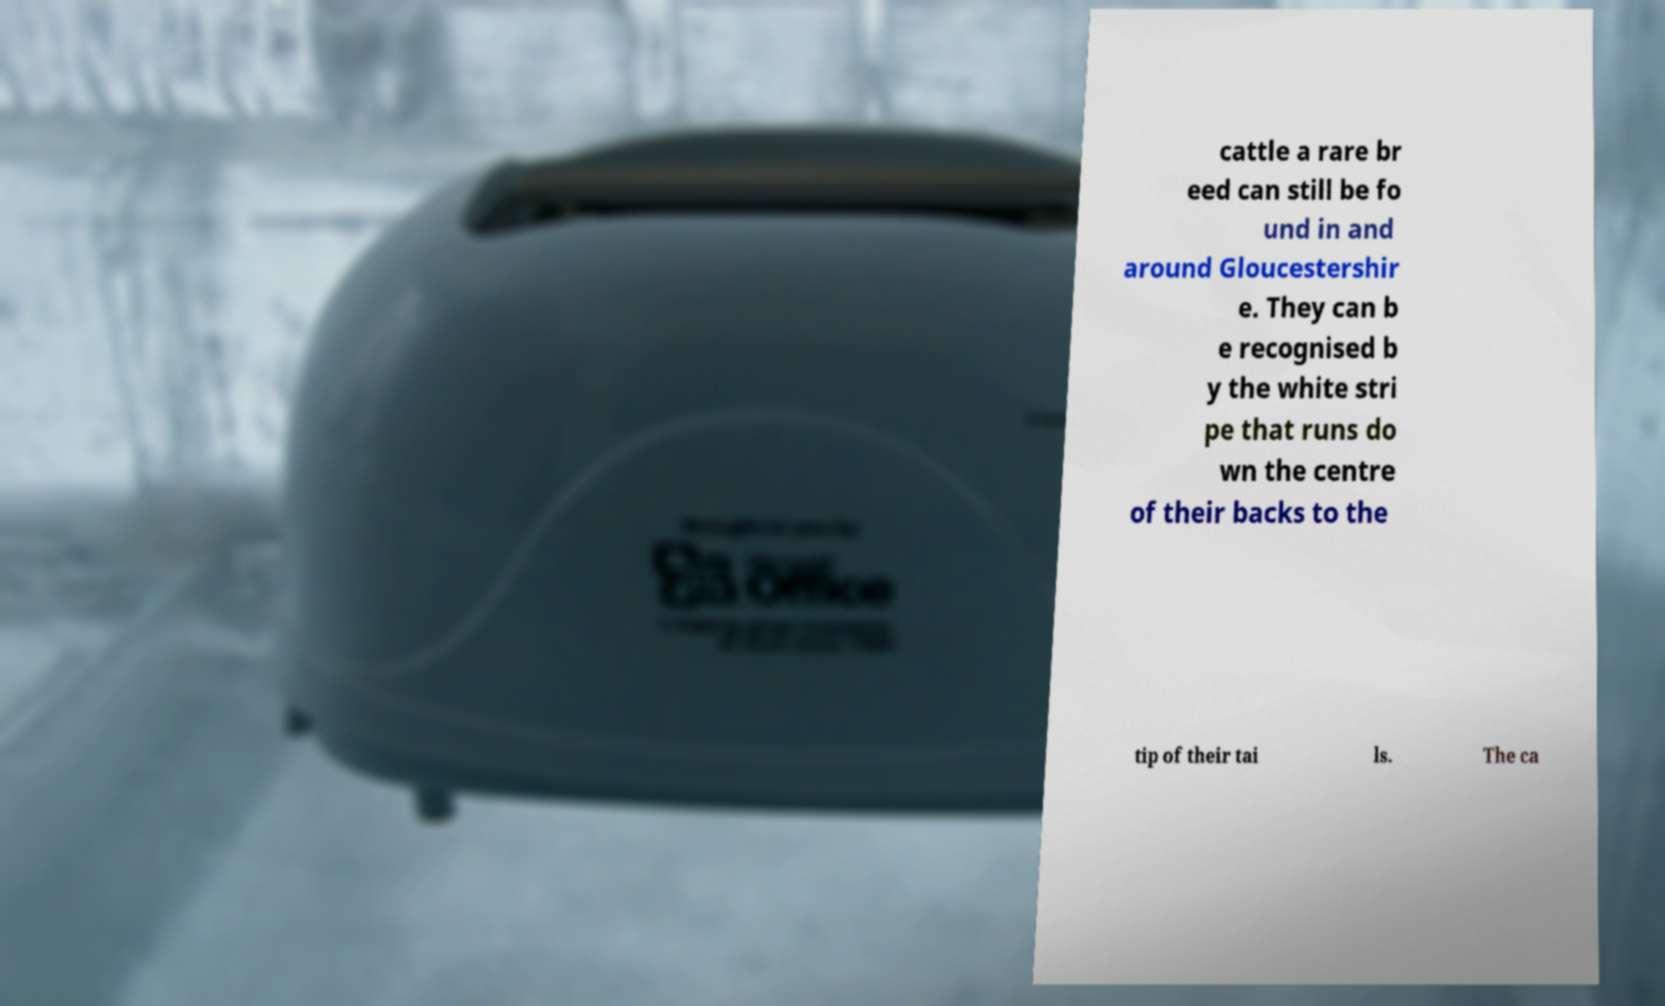Could you extract and type out the text from this image? cattle a rare br eed can still be fo und in and around Gloucestershir e. They can b e recognised b y the white stri pe that runs do wn the centre of their backs to the tip of their tai ls. The ca 